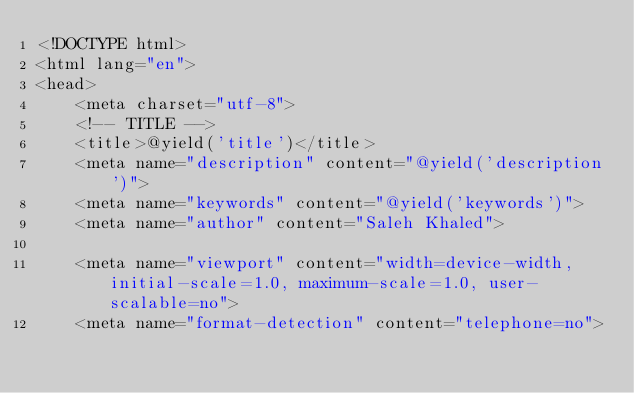<code> <loc_0><loc_0><loc_500><loc_500><_PHP_><!DOCTYPE html>
<html lang="en">
<head>
    <meta charset="utf-8">
    <!-- TITLE -->
    <title>@yield('title')</title>
    <meta name="description" content="@yield('description')">
    <meta name="keywords" content="@yield('keywords')">
    <meta name="author" content="Saleh Khaled">

    <meta name="viewport" content="width=device-width, initial-scale=1.0, maximum-scale=1.0, user-scalable=no">
    <meta name="format-detection" content="telephone=no"></code> 